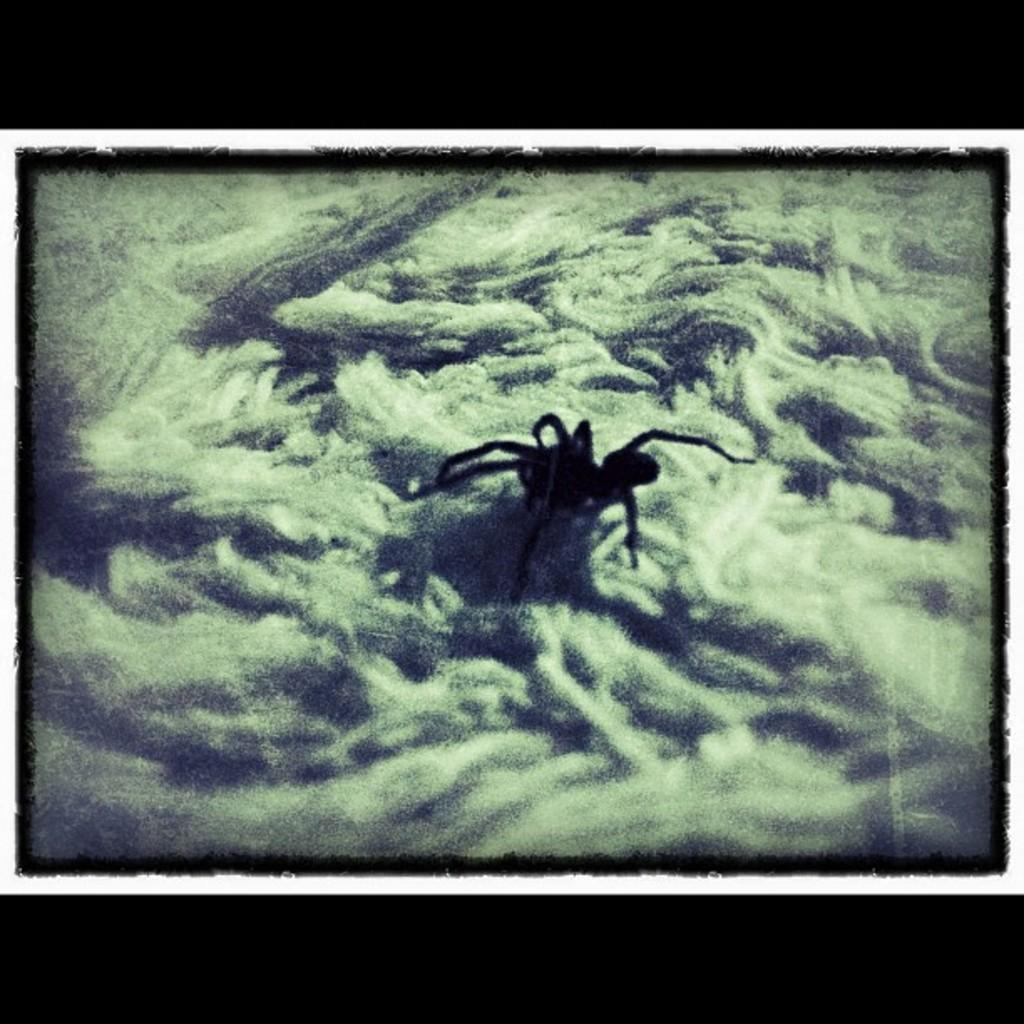What type of creature can be seen in the image? There is an insect in the image. What is the insect doing or resting on in the image? The insect is on an object in the image. What type of grain is being sold in the shop in the image? There is no shop or grain present in the image; it features an insect on an object. How many eyes does the insect have in the image? The number of eyes the insect has cannot be determined from the image alone, as insects can have varying numbers of eyes depending on the species. 